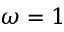<formula> <loc_0><loc_0><loc_500><loc_500>\omega = 1</formula> 